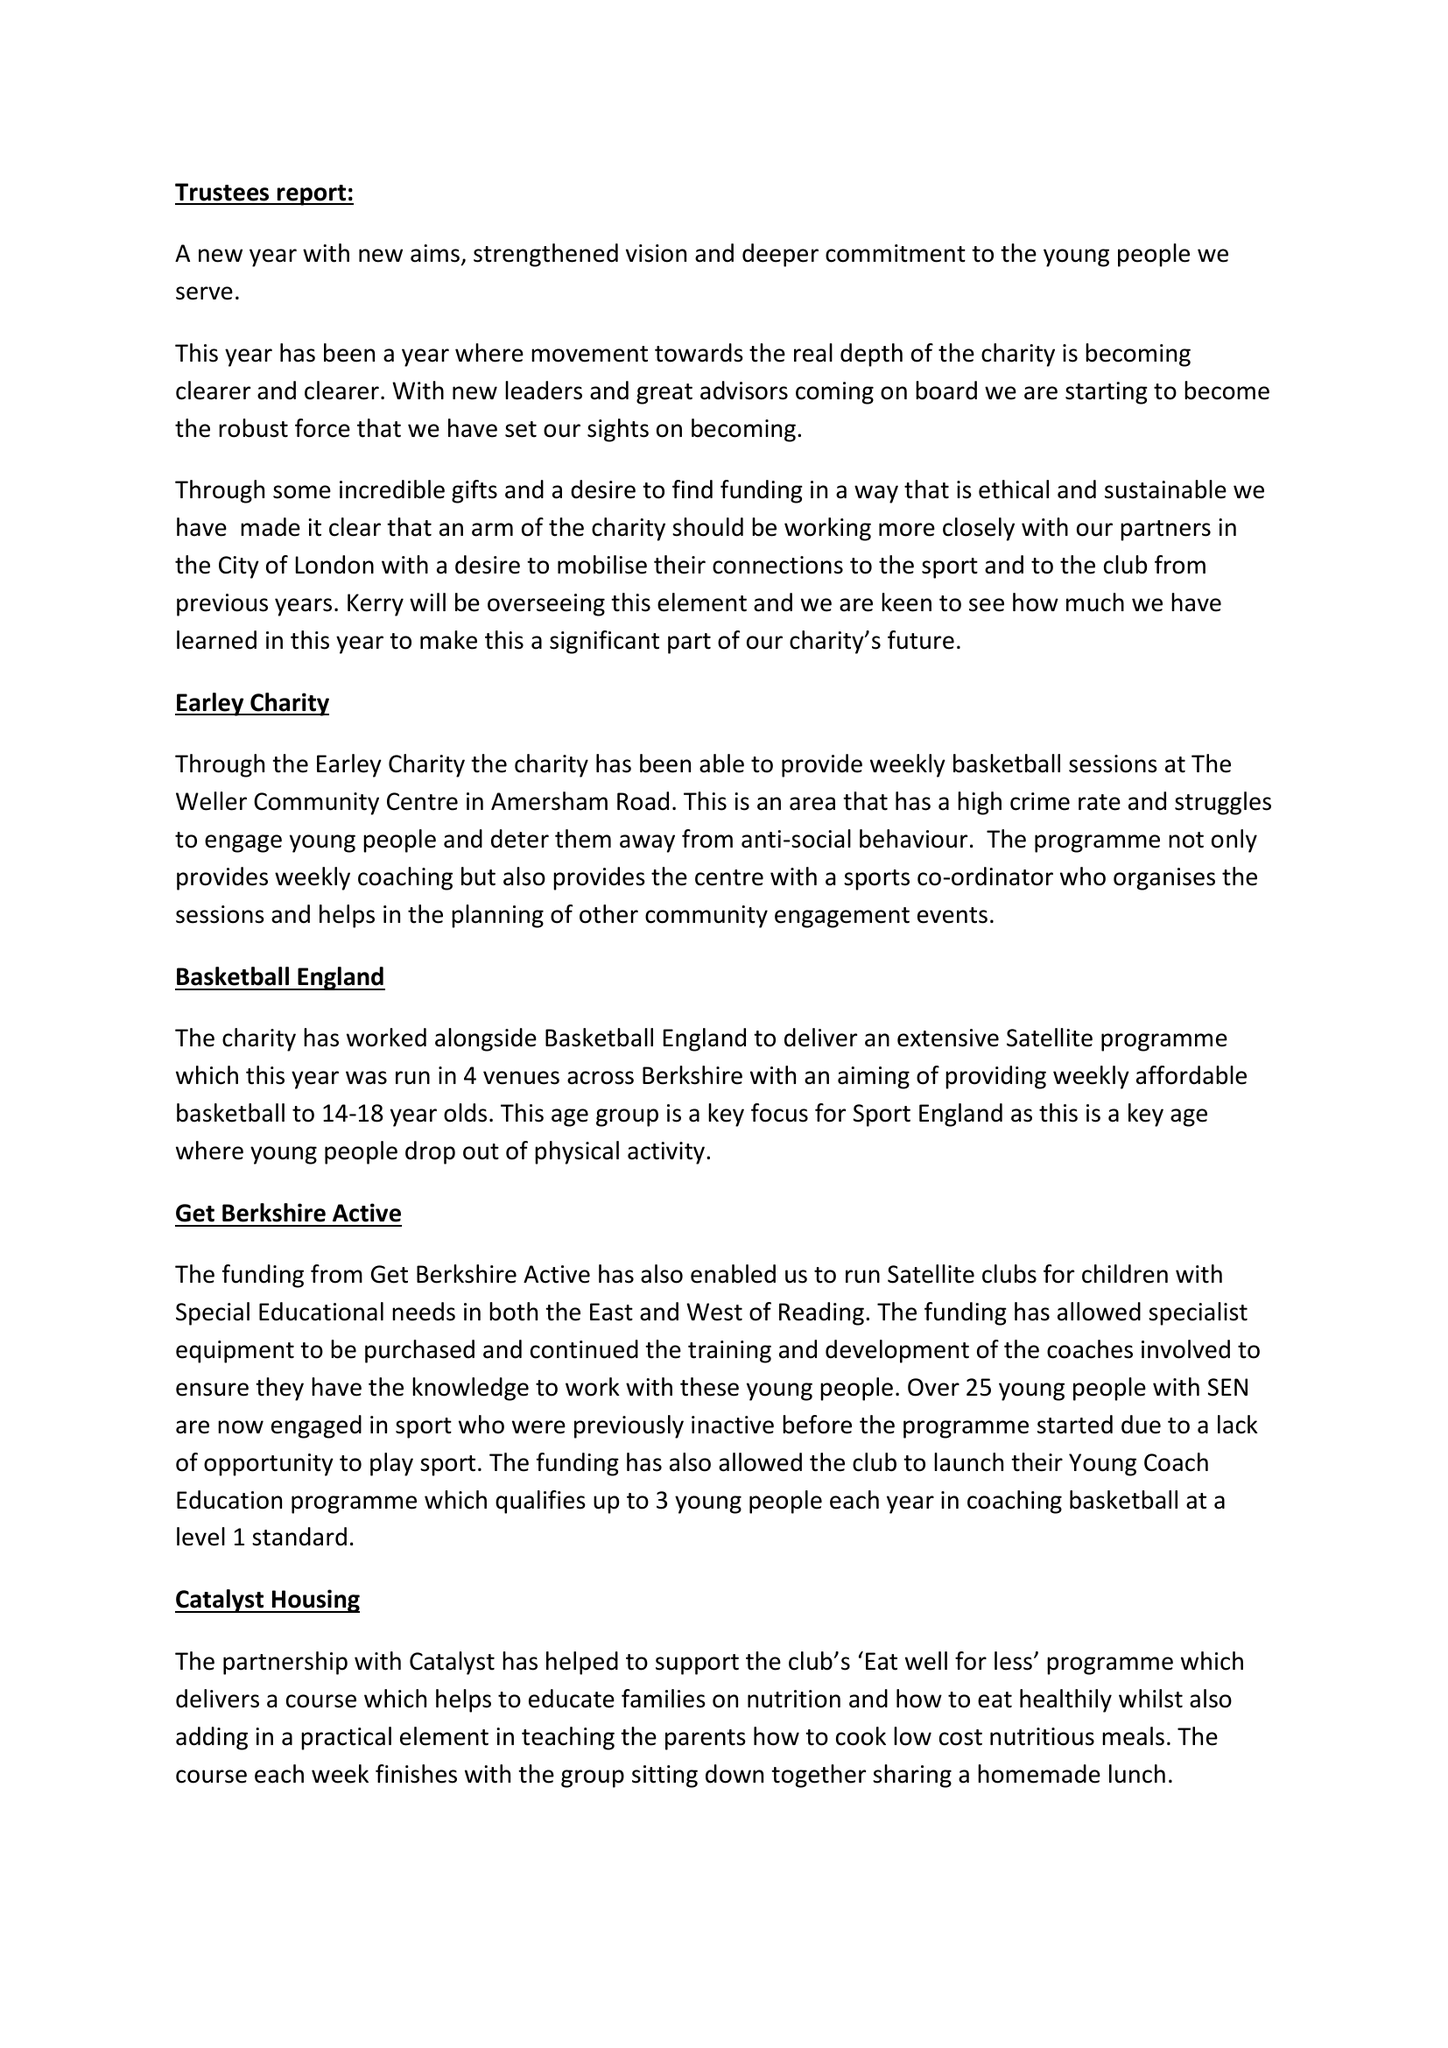What is the value for the income_annually_in_british_pounds?
Answer the question using a single word or phrase. 36905.00 